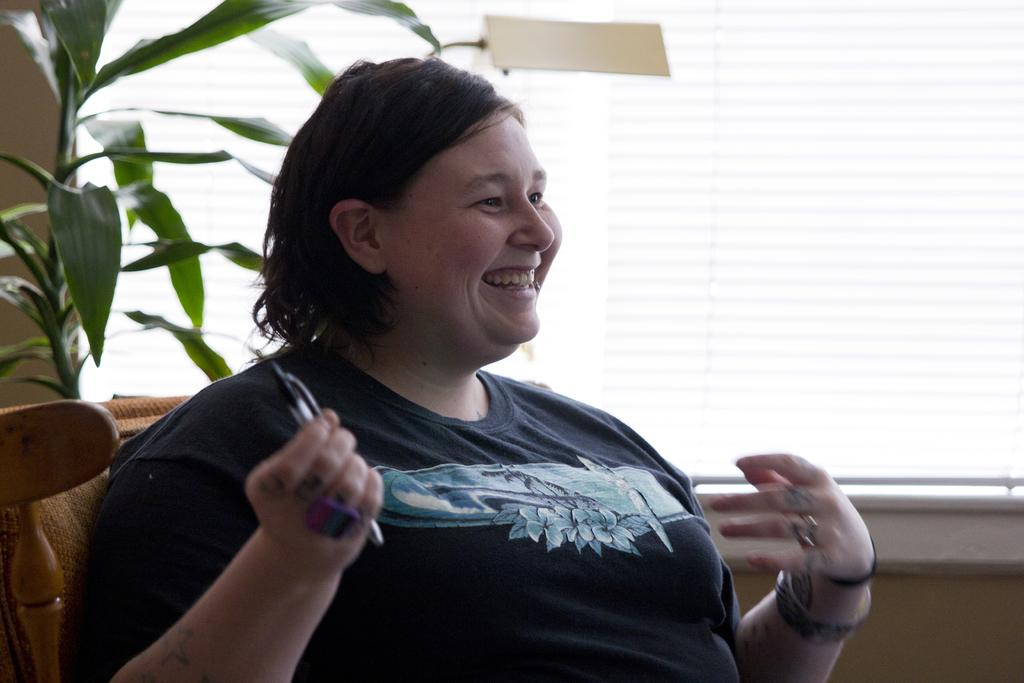Who is present in the image? There is a woman in the image. What is the woman doing in the image? The woman is sitting and smiling. What is the woman holding in her hand? The woman is holding a pen in her hand. What can be seen in the background of the image? There is a houseplant with leaves and a window in the image. What trick did the woman perform with the top in the image? There is no top present in the image, and the woman is not performing any tricks. 